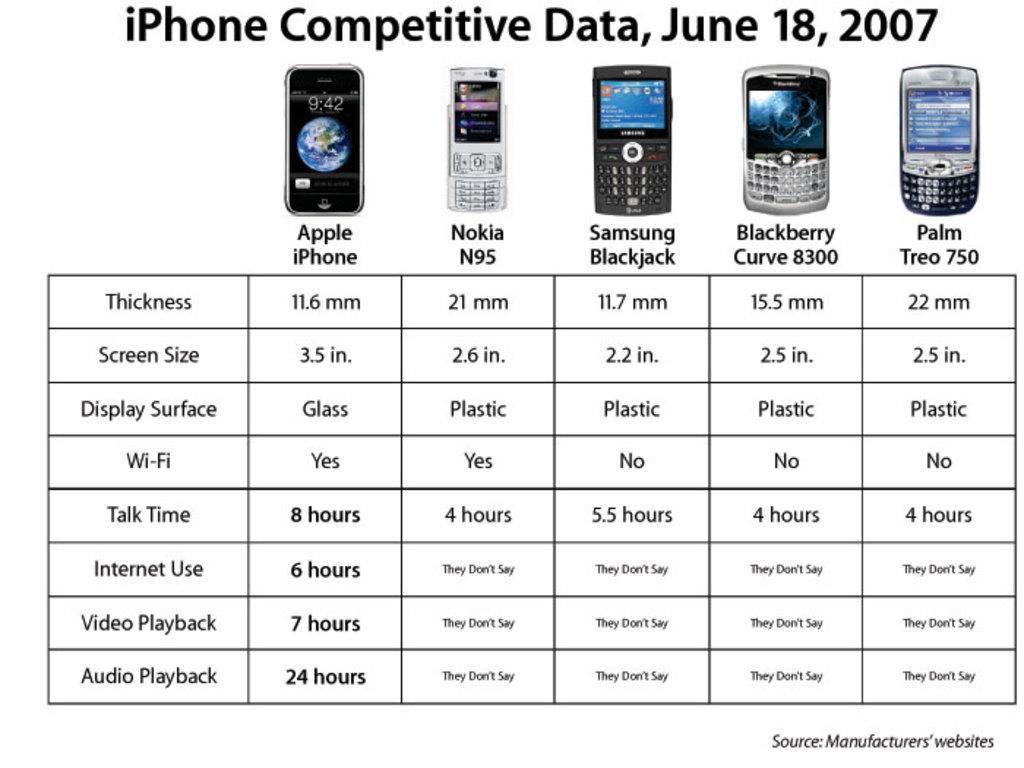Provide a one-sentence caption for the provided image. An infograqphic comparing iPhones to other phones manufactured in 2007. 